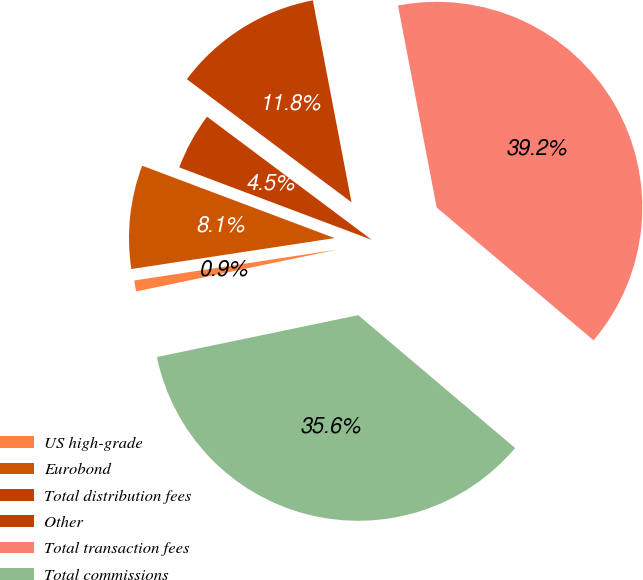<chart> <loc_0><loc_0><loc_500><loc_500><pie_chart><fcel>US high-grade<fcel>Eurobond<fcel>Total distribution fees<fcel>Other<fcel>Total transaction fees<fcel>Total commissions<nl><fcel>0.86%<fcel>8.13%<fcel>4.49%<fcel>11.77%<fcel>39.19%<fcel>35.55%<nl></chart> 